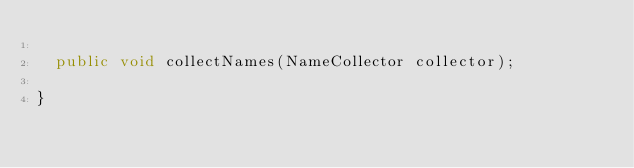Convert code to text. <code><loc_0><loc_0><loc_500><loc_500><_Java_>
  public void collectNames(NameCollector collector);

}
</code> 